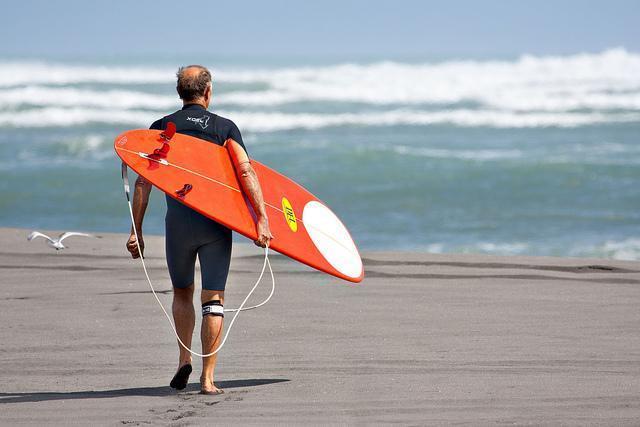How many surfboards are in the photo?
Give a very brief answer. 1. 